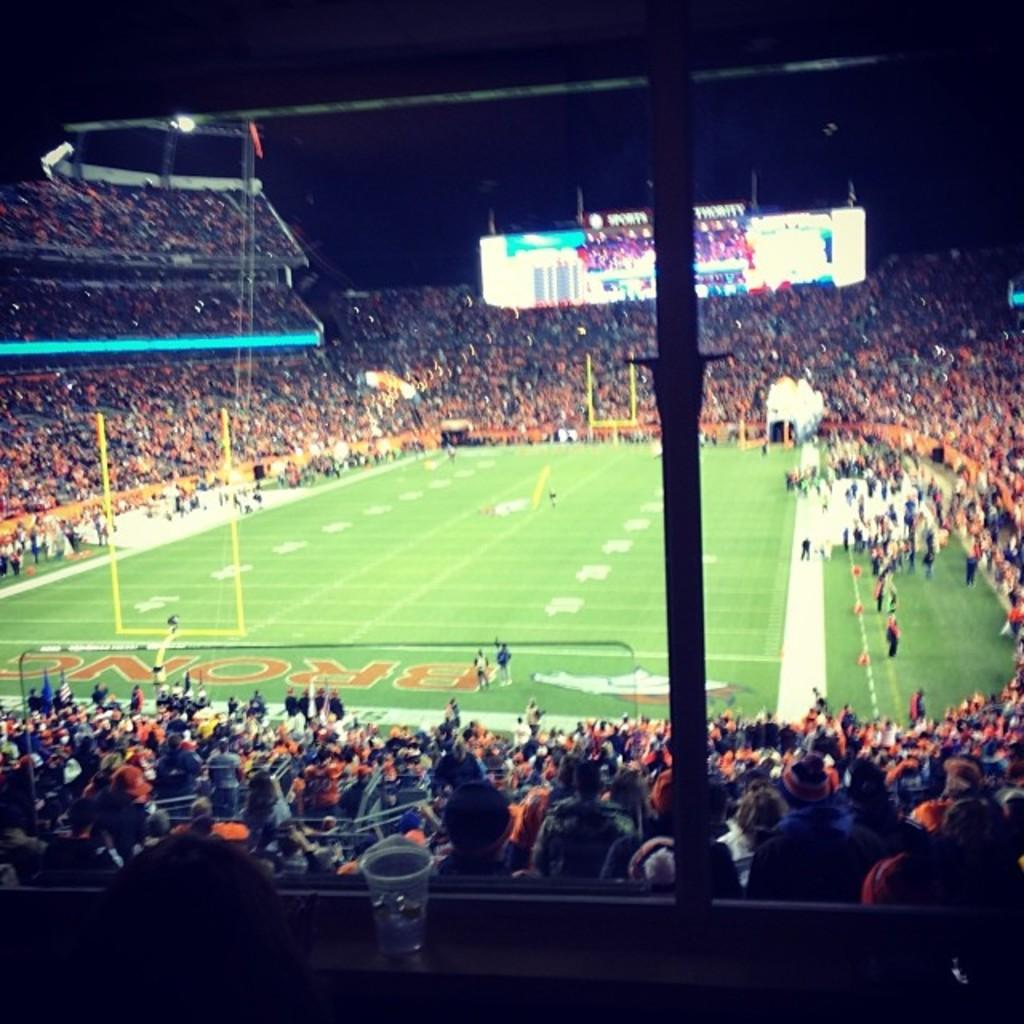What is happening in the image involving people? There are people on the ground and in the stands in the image. What structures are present in the image? There are goal posts in the image. What additional feature can be seen in the image? There is a display screen in the image. What can be observed on the ground in the image? There are marks on the ground in the image. What type of scarf is being worn by the people in the image? There is no mention of scarves being worn by the people in the image. 